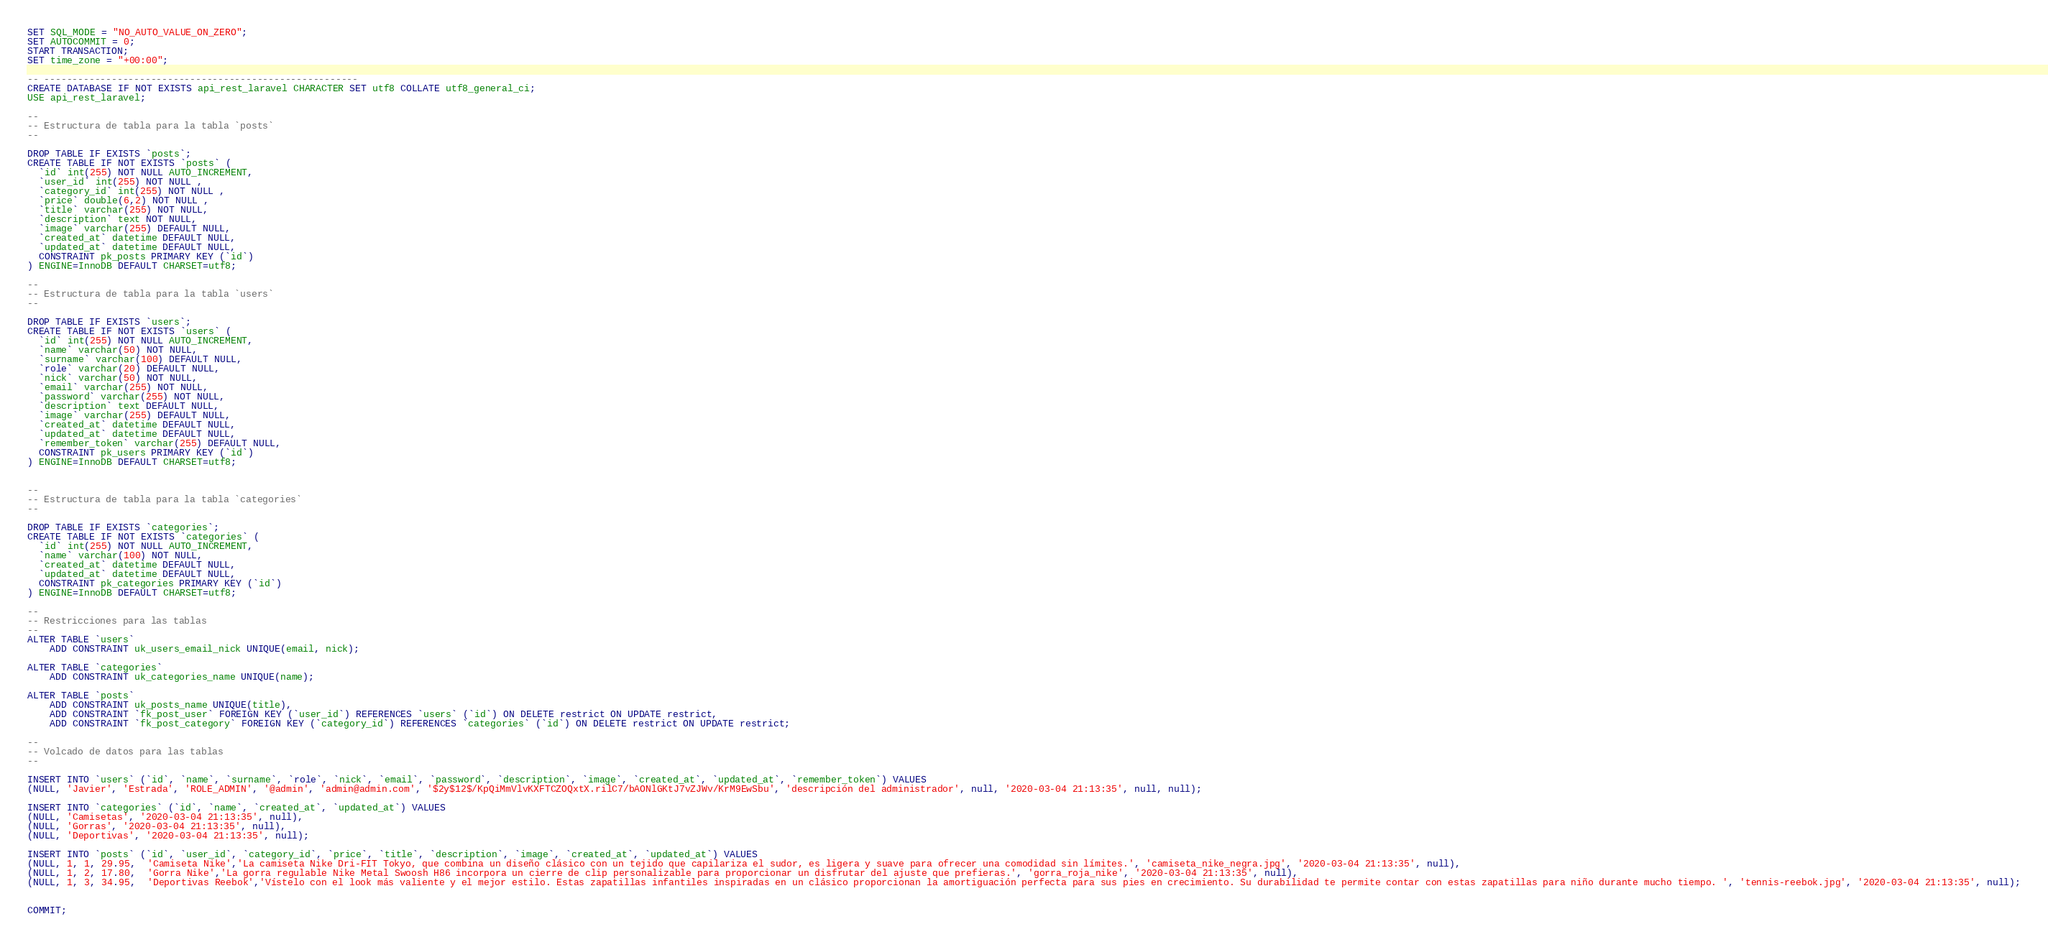<code> <loc_0><loc_0><loc_500><loc_500><_SQL_>SET SQL_MODE = "NO_AUTO_VALUE_ON_ZERO";
SET AUTOCOMMIT = 0;
START TRANSACTION;
SET time_zone = "+00:00";

-- --------------------------------------------------------
CREATE DATABASE IF NOT EXISTS api_rest_laravel CHARACTER SET utf8 COLLATE utf8_general_ci;
USE api_rest_laravel;

--
-- Estructura de tabla para la tabla `posts`
--

DROP TABLE IF EXISTS `posts`;
CREATE TABLE IF NOT EXISTS `posts` (
  `id` int(255) NOT NULL AUTO_INCREMENT,
  `user_id` int(255) NOT NULL ,
  `category_id` int(255) NOT NULL ,
  `price` double(6,2) NOT NULL ,
  `title` varchar(255) NOT NULL,
  `description` text NOT NULL,
  `image` varchar(255) DEFAULT NULL,
  `created_at` datetime DEFAULT NULL,
  `updated_at` datetime DEFAULT NULL,
  CONSTRAINT pk_posts PRIMARY KEY (`id`)
) ENGINE=InnoDB DEFAULT CHARSET=utf8;

--
-- Estructura de tabla para la tabla `users`
--

DROP TABLE IF EXISTS `users`;
CREATE TABLE IF NOT EXISTS `users` (
  `id` int(255) NOT NULL AUTO_INCREMENT,
  `name` varchar(50) NOT NULL,
  `surname` varchar(100) DEFAULT NULL,
  `role` varchar(20) DEFAULT NULL,
  `nick` varchar(50) NOT NULL,
  `email` varchar(255) NOT NULL,
  `password` varchar(255) NOT NULL,
  `description` text DEFAULT NULL,
  `image` varchar(255) DEFAULT NULL,
  `created_at` datetime DEFAULT NULL,
  `updated_at` datetime DEFAULT NULL,
  `remember_token` varchar(255) DEFAULT NULL,
  CONSTRAINT pk_users PRIMARY KEY (`id`)
) ENGINE=InnoDB DEFAULT CHARSET=utf8;


--
-- Estructura de tabla para la tabla `categories`
--

DROP TABLE IF EXISTS `categories`;
CREATE TABLE IF NOT EXISTS `categories` (
  `id` int(255) NOT NULL AUTO_INCREMENT,
  `name` varchar(100) NOT NULL,
  `created_at` datetime DEFAULT NULL,
  `updated_at` datetime DEFAULT NULL,
  CONSTRAINT pk_categories PRIMARY KEY (`id`)
) ENGINE=InnoDB DEFAULT CHARSET=utf8;

--
-- Restricciones para las tablas
--
ALTER TABLE `users`
    ADD CONSTRAINT uk_users_email_nick UNIQUE(email, nick);

ALTER TABLE `categories`
    ADD CONSTRAINT uk_categories_name UNIQUE(name);

ALTER TABLE `posts`
    ADD CONSTRAINT uk_posts_name UNIQUE(title),
    ADD CONSTRAINT `fk_post_user` FOREIGN KEY (`user_id`) REFERENCES `users` (`id`) ON DELETE restrict ON UPDATE restrict,
    ADD CONSTRAINT `fk_post_category` FOREIGN KEY (`category_id`) REFERENCES `categories` (`id`) ON DELETE restrict ON UPDATE restrict;

--
-- Volcado de datos para las tablas
--

INSERT INTO `users` (`id`, `name`, `surname`, `role`, `nick`, `email`, `password`, `description`, `image`, `created_at`, `updated_at`, `remember_token`) VALUES
(NULL, 'Javier', 'Estrada', 'ROLE_ADMIN', '@admin', 'admin@admin.com', '$2y$12$/KpQiMmVlvKXFTCZOQxtX.rilC7/bAONlGKtJ7vZJWv/KrM9EwSbu', 'descripción del administrador', null, '2020-03-04 21:13:35', null, null);

INSERT INTO `categories` (`id`, `name`, `created_at`, `updated_at`) VALUES
(NULL, 'Camisetas', '2020-03-04 21:13:35', null),
(NULL, 'Gorras', '2020-03-04 21:13:35', null),
(NULL, 'Deportivas', '2020-03-04 21:13:35', null);

INSERT INTO `posts` (`id`, `user_id`, `category_id`, `price`, `title`, `description`, `image`, `created_at`, `updated_at`) VALUES
(NULL, 1, 1, 29.95,  'Camiseta Nike','La camiseta Nike Dri-FIT Tokyo, que combina un diseño clásico con un tejido que capilariza el sudor, es ligera y suave para ofrecer una comodidad sin límites.', 'camiseta_nike_negra.jpg', '2020-03-04 21:13:35', null),
(NULL, 1, 2, 17.80,  'Gorra Nike','La gorra regulable Nike Metal Swoosh H86 incorpora un cierre de clip personalizable para proporcionar un disfrutar del ajuste que prefieras.', 'gorra_roja_nike', '2020-03-04 21:13:35', null),
(NULL, 1, 3, 34.95,  'Deportivas Reebok','Vístelo con el look más valiente y el mejor estilo. Estas zapatillas infantiles inspiradas en un clásico proporcionan la amortiguación perfecta para sus pies en crecimiento. Su durabilidad te permite contar con estas zapatillas para niño durante mucho tiempo. ', 'tennis-reebok.jpg', '2020-03-04 21:13:35', null);


COMMIT;
</code> 